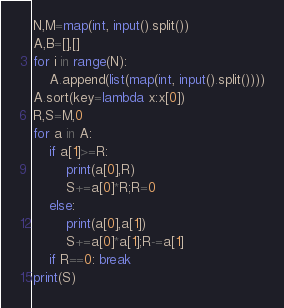Convert code to text. <code><loc_0><loc_0><loc_500><loc_500><_Python_>N,M=map(int, input().split())
A,B=[],[]
for i in range(N):
    A.append(list(map(int, input().split())))
A.sort(key=lambda x:x[0])
R,S=M,0
for a in A:
    if a[1]>=R:
        print(a[0],R)
        S+=a[0]*R;R=0
    else:
        print(a[0],a[1])
        S+=a[0]*a[1];R-=a[1]
    if R==0: break
print(S)

</code> 